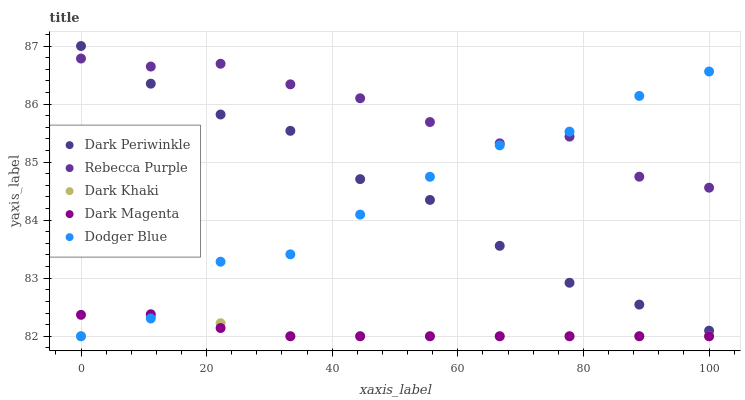Does Dark Khaki have the minimum area under the curve?
Answer yes or no. Yes. Does Rebecca Purple have the maximum area under the curve?
Answer yes or no. Yes. Does Dodger Blue have the minimum area under the curve?
Answer yes or no. No. Does Dodger Blue have the maximum area under the curve?
Answer yes or no. No. Is Dark Magenta the smoothest?
Answer yes or no. Yes. Is Dodger Blue the roughest?
Answer yes or no. Yes. Is Dark Periwinkle the smoothest?
Answer yes or no. No. Is Dark Periwinkle the roughest?
Answer yes or no. No. Does Dark Khaki have the lowest value?
Answer yes or no. Yes. Does Dark Periwinkle have the lowest value?
Answer yes or no. No. Does Dark Periwinkle have the highest value?
Answer yes or no. Yes. Does Dodger Blue have the highest value?
Answer yes or no. No. Is Dark Khaki less than Dark Periwinkle?
Answer yes or no. Yes. Is Dark Periwinkle greater than Dark Magenta?
Answer yes or no. Yes. Does Dark Magenta intersect Dark Khaki?
Answer yes or no. Yes. Is Dark Magenta less than Dark Khaki?
Answer yes or no. No. Is Dark Magenta greater than Dark Khaki?
Answer yes or no. No. Does Dark Khaki intersect Dark Periwinkle?
Answer yes or no. No. 